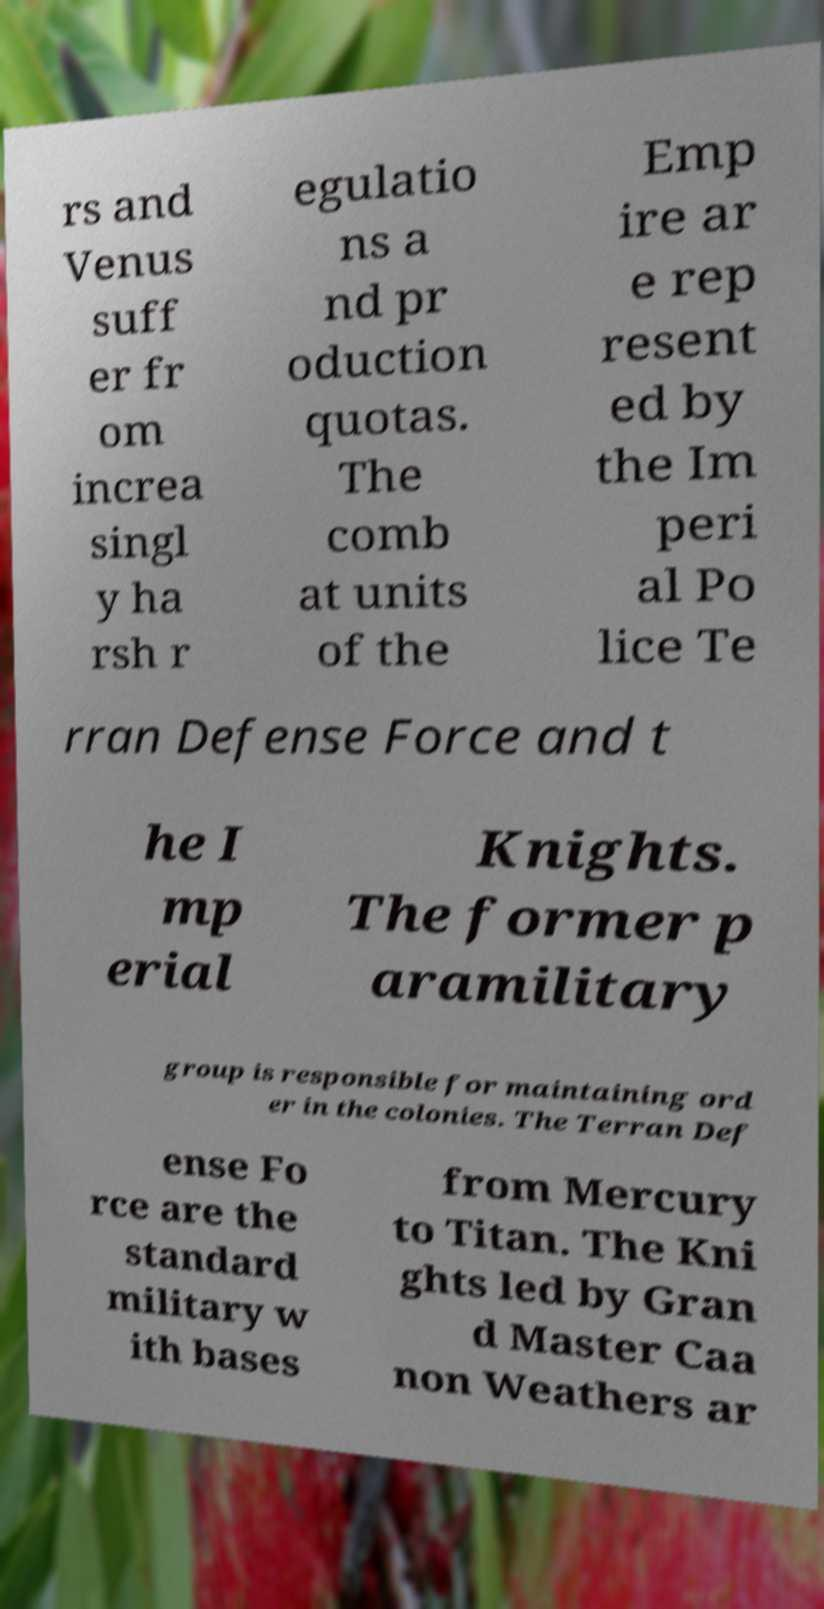Can you read and provide the text displayed in the image?This photo seems to have some interesting text. Can you extract and type it out for me? rs and Venus suff er fr om increa singl y ha rsh r egulatio ns a nd pr oduction quotas. The comb at units of the Emp ire ar e rep resent ed by the Im peri al Po lice Te rran Defense Force and t he I mp erial Knights. The former p aramilitary group is responsible for maintaining ord er in the colonies. The Terran Def ense Fo rce are the standard military w ith bases from Mercury to Titan. The Kni ghts led by Gran d Master Caa non Weathers ar 